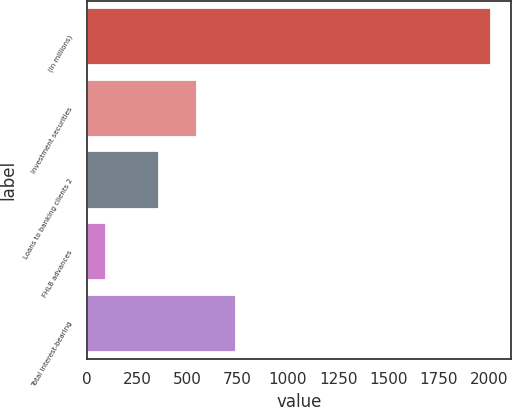Convert chart. <chart><loc_0><loc_0><loc_500><loc_500><bar_chart><fcel>(in millions)<fcel>Investment securities<fcel>Loans to banking clients 2<fcel>FHLB advances<fcel>Total interest-bearing<nl><fcel>2009<fcel>549.15<fcel>357.6<fcel>93.5<fcel>740.7<nl></chart> 